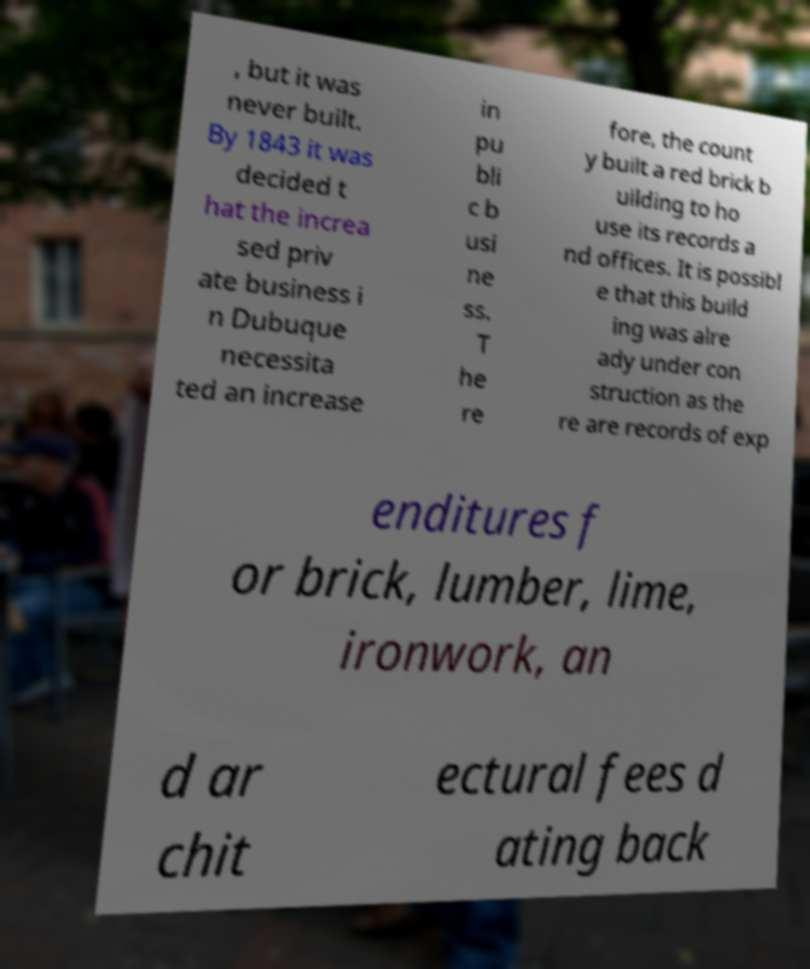I need the written content from this picture converted into text. Can you do that? , but it was never built. By 1843 it was decided t hat the increa sed priv ate business i n Dubuque necessita ted an increase in pu bli c b usi ne ss. T he re fore, the count y built a red brick b uilding to ho use its records a nd offices. It is possibl e that this build ing was alre ady under con struction as the re are records of exp enditures f or brick, lumber, lime, ironwork, an d ar chit ectural fees d ating back 